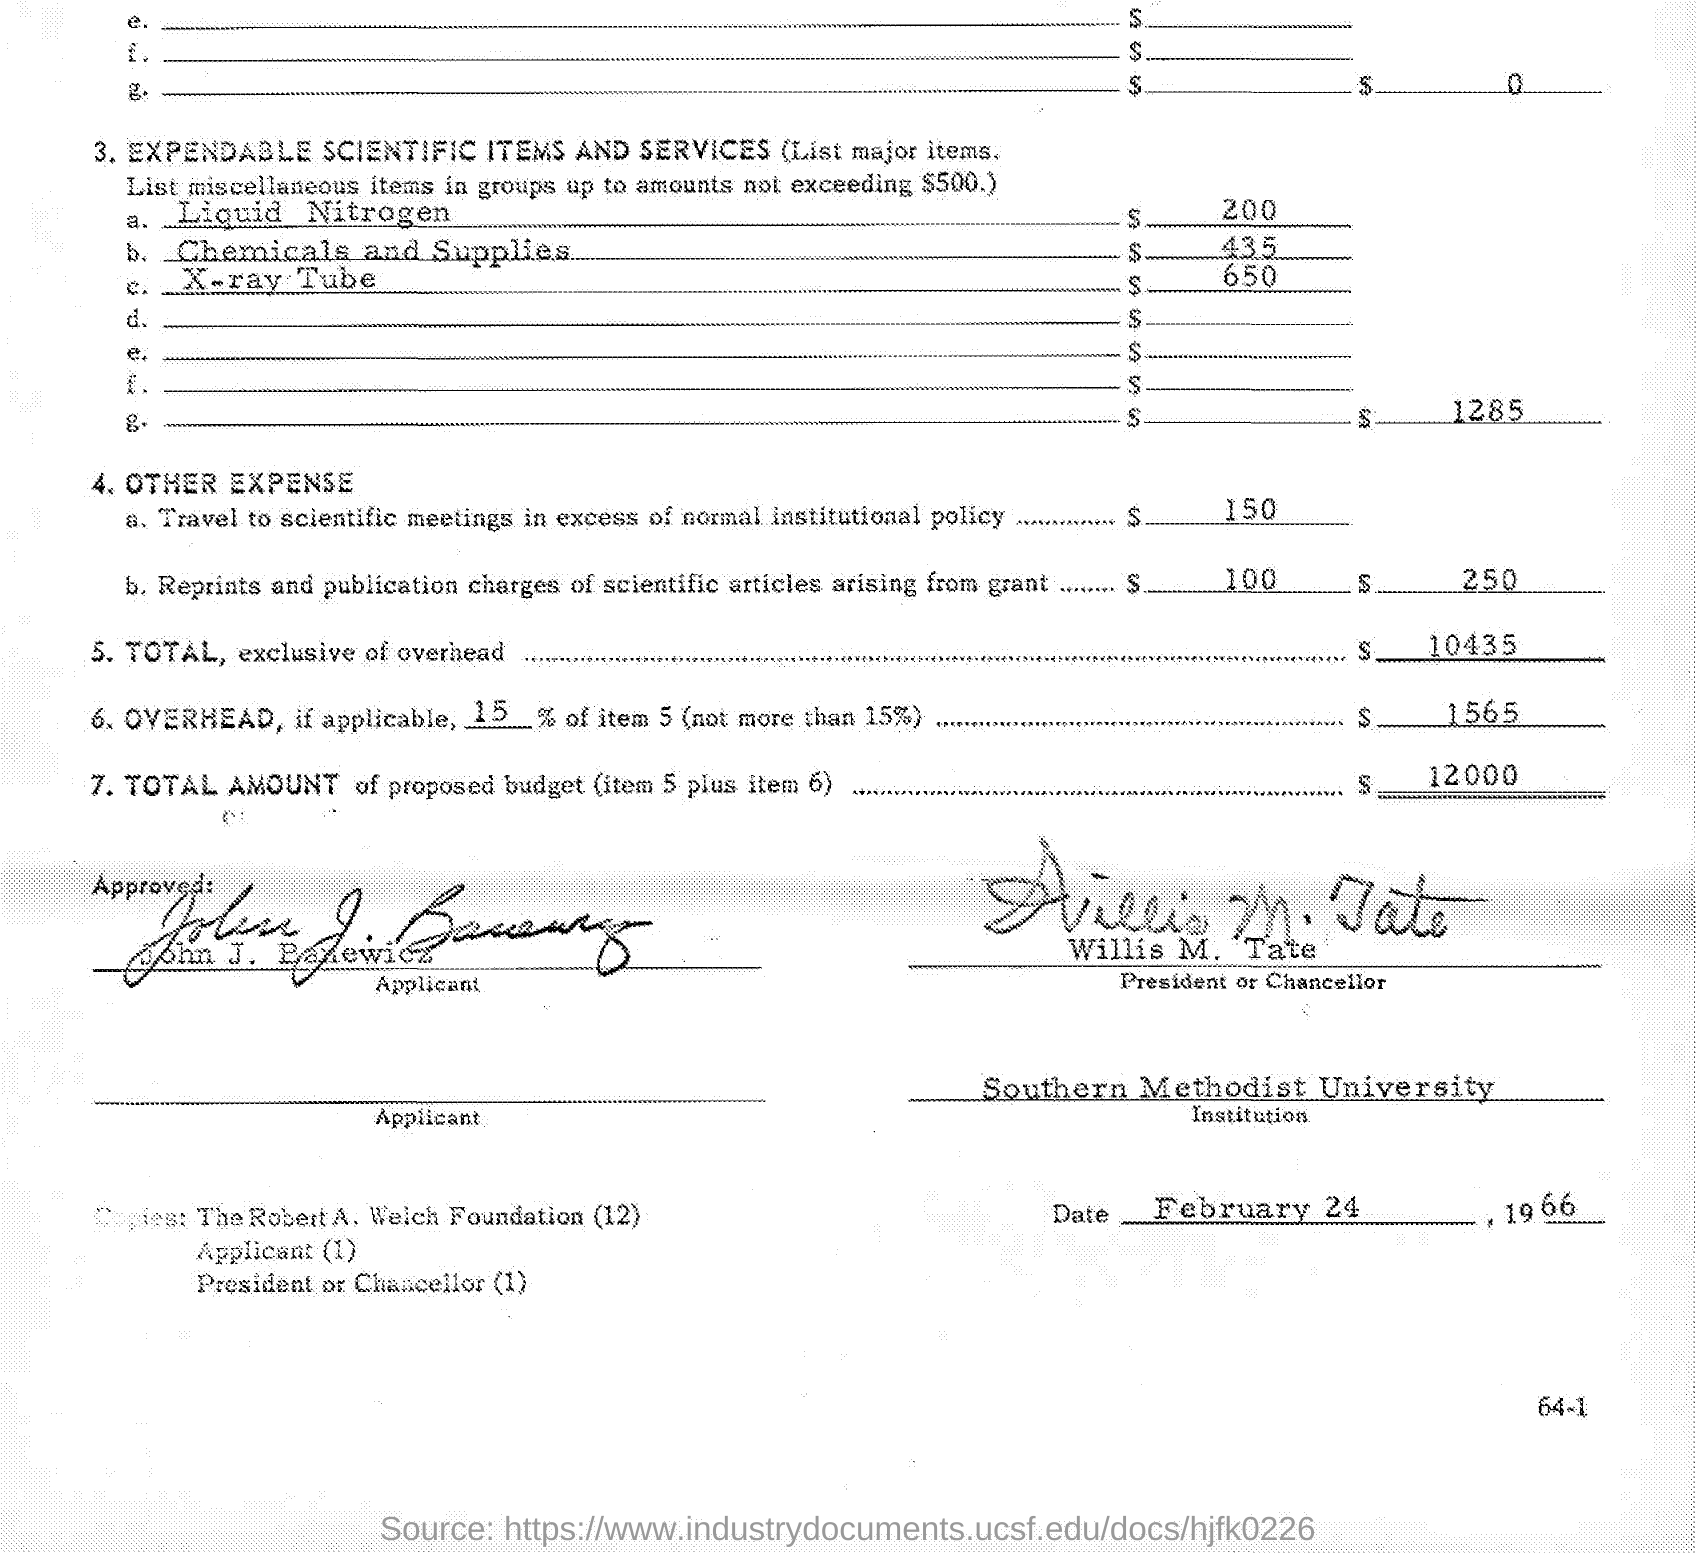What is the TOTAL, exclusive of overhead?
Offer a very short reply. $10435. Who is the President or Chancellor?
Make the answer very short. Willis M. Tate. When is the document dated?
Your response must be concise. FEBRUARY 24, 1966. Which institution is mentioned?
Provide a short and direct response. SOUTHERN METHODIST UNIVERSITY. 